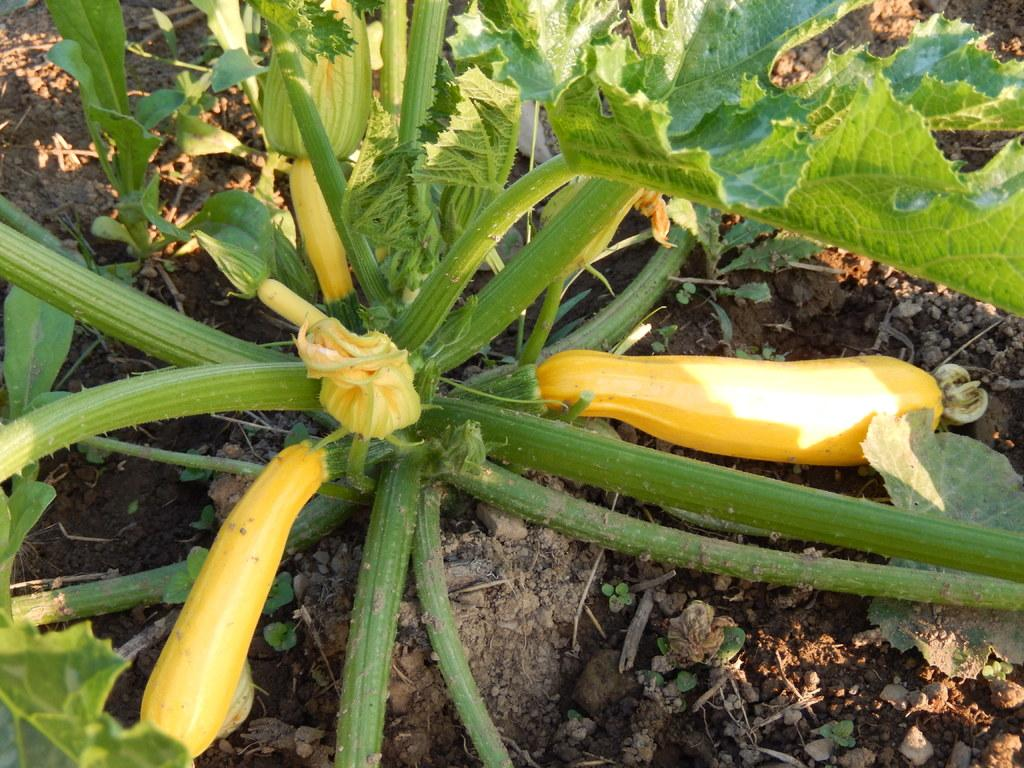What is the main subject in the middle of the image? There is a plant in the middle of the image. What type of vegetables are near the plant? There are yellow color vegetables near the plant. What can be seen at the bottom of the image? There is soil at the bottom of the image. What is placed on the soil? There are stones on the soil. What advertisement can be seen on the plant in the image? There is no advertisement present on the plant in the image. What type of mint is growing near the plant? There is no mint present in the image. 